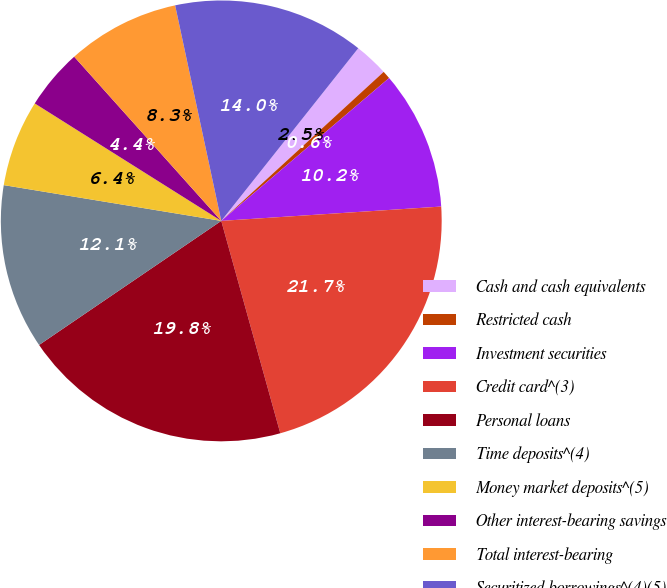Convert chart to OTSL. <chart><loc_0><loc_0><loc_500><loc_500><pie_chart><fcel>Cash and cash equivalents<fcel>Restricted cash<fcel>Investment securities<fcel>Credit card^(3)<fcel>Personal loans<fcel>Time deposits^(4)<fcel>Money market deposits^(5)<fcel>Other interest-bearing savings<fcel>Total interest-bearing<fcel>Securitized borrowings^(4)(5)<nl><fcel>2.51%<fcel>0.59%<fcel>10.19%<fcel>21.72%<fcel>19.8%<fcel>12.11%<fcel>6.35%<fcel>4.43%<fcel>8.27%<fcel>14.03%<nl></chart> 